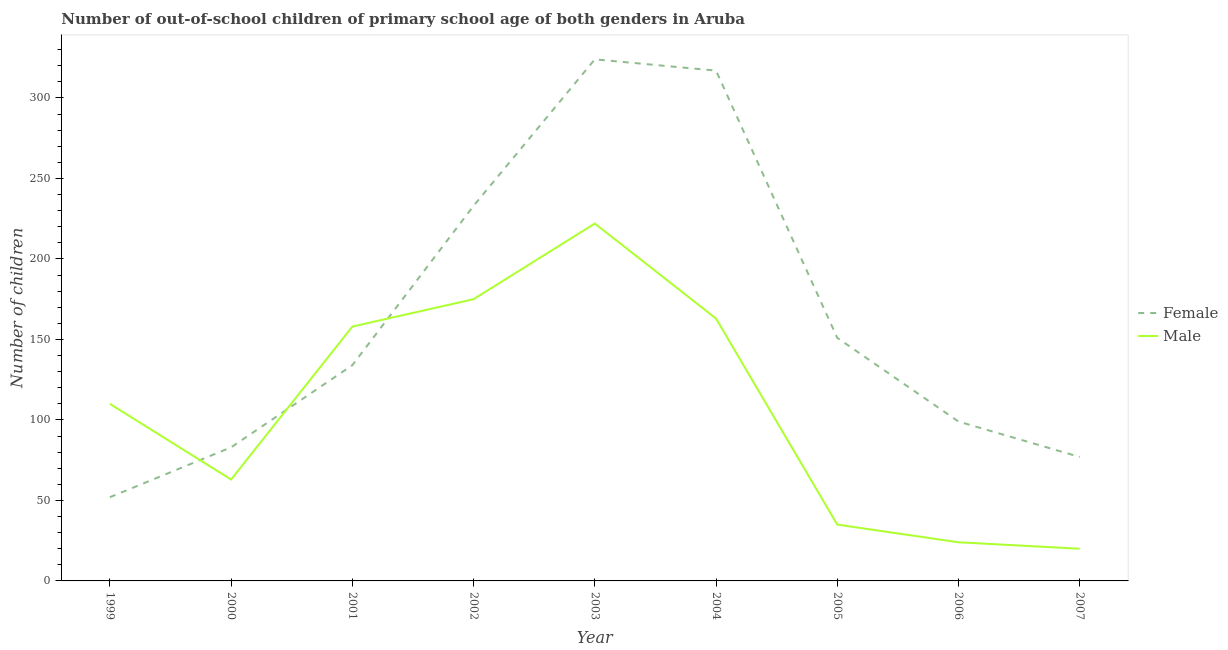Is the number of lines equal to the number of legend labels?
Your answer should be very brief. Yes. What is the number of female out-of-school students in 2006?
Make the answer very short. 99. Across all years, what is the maximum number of female out-of-school students?
Your response must be concise. 324. Across all years, what is the minimum number of male out-of-school students?
Your answer should be very brief. 20. In which year was the number of female out-of-school students maximum?
Offer a terse response. 2003. In which year was the number of male out-of-school students minimum?
Offer a very short reply. 2007. What is the total number of female out-of-school students in the graph?
Make the answer very short. 1470. What is the difference between the number of female out-of-school students in 2001 and that in 2003?
Your answer should be compact. -190. What is the difference between the number of male out-of-school students in 2006 and the number of female out-of-school students in 2002?
Make the answer very short. -209. What is the average number of female out-of-school students per year?
Provide a short and direct response. 163.33. In the year 2007, what is the difference between the number of female out-of-school students and number of male out-of-school students?
Make the answer very short. 57. What is the ratio of the number of male out-of-school students in 2002 to that in 2004?
Your response must be concise. 1.07. Is the number of female out-of-school students in 1999 less than that in 2007?
Make the answer very short. Yes. Is the difference between the number of male out-of-school students in 2000 and 2002 greater than the difference between the number of female out-of-school students in 2000 and 2002?
Your answer should be compact. Yes. What is the difference between the highest and the lowest number of female out-of-school students?
Your answer should be very brief. 272. In how many years, is the number of female out-of-school students greater than the average number of female out-of-school students taken over all years?
Your response must be concise. 3. Is the number of male out-of-school students strictly greater than the number of female out-of-school students over the years?
Offer a very short reply. No. Is the number of male out-of-school students strictly less than the number of female out-of-school students over the years?
Make the answer very short. No. How many lines are there?
Give a very brief answer. 2. Are the values on the major ticks of Y-axis written in scientific E-notation?
Your response must be concise. No. Does the graph contain grids?
Keep it short and to the point. No. Where does the legend appear in the graph?
Make the answer very short. Center right. How many legend labels are there?
Provide a short and direct response. 2. How are the legend labels stacked?
Your response must be concise. Vertical. What is the title of the graph?
Your answer should be very brief. Number of out-of-school children of primary school age of both genders in Aruba. What is the label or title of the Y-axis?
Ensure brevity in your answer.  Number of children. What is the Number of children in Male in 1999?
Provide a short and direct response. 110. What is the Number of children in Female in 2000?
Offer a terse response. 83. What is the Number of children of Female in 2001?
Your answer should be very brief. 134. What is the Number of children of Male in 2001?
Your response must be concise. 158. What is the Number of children of Female in 2002?
Provide a short and direct response. 233. What is the Number of children in Male in 2002?
Offer a terse response. 175. What is the Number of children of Female in 2003?
Keep it short and to the point. 324. What is the Number of children of Male in 2003?
Provide a succinct answer. 222. What is the Number of children in Female in 2004?
Provide a short and direct response. 317. What is the Number of children of Male in 2004?
Give a very brief answer. 163. What is the Number of children of Female in 2005?
Your response must be concise. 151. What is the Number of children in Male in 2005?
Your response must be concise. 35. What is the Number of children of Female in 2006?
Your answer should be compact. 99. Across all years, what is the maximum Number of children in Female?
Keep it short and to the point. 324. Across all years, what is the maximum Number of children of Male?
Offer a very short reply. 222. Across all years, what is the minimum Number of children of Female?
Provide a short and direct response. 52. What is the total Number of children in Female in the graph?
Ensure brevity in your answer.  1470. What is the total Number of children in Male in the graph?
Ensure brevity in your answer.  970. What is the difference between the Number of children in Female in 1999 and that in 2000?
Your answer should be compact. -31. What is the difference between the Number of children in Female in 1999 and that in 2001?
Your answer should be very brief. -82. What is the difference between the Number of children of Male in 1999 and that in 2001?
Your answer should be very brief. -48. What is the difference between the Number of children in Female in 1999 and that in 2002?
Make the answer very short. -181. What is the difference between the Number of children of Male in 1999 and that in 2002?
Ensure brevity in your answer.  -65. What is the difference between the Number of children of Female in 1999 and that in 2003?
Make the answer very short. -272. What is the difference between the Number of children in Male in 1999 and that in 2003?
Make the answer very short. -112. What is the difference between the Number of children in Female in 1999 and that in 2004?
Offer a very short reply. -265. What is the difference between the Number of children of Male in 1999 and that in 2004?
Your response must be concise. -53. What is the difference between the Number of children in Female in 1999 and that in 2005?
Your answer should be compact. -99. What is the difference between the Number of children in Male in 1999 and that in 2005?
Provide a short and direct response. 75. What is the difference between the Number of children in Female in 1999 and that in 2006?
Offer a very short reply. -47. What is the difference between the Number of children of Male in 1999 and that in 2007?
Give a very brief answer. 90. What is the difference between the Number of children in Female in 2000 and that in 2001?
Give a very brief answer. -51. What is the difference between the Number of children in Male in 2000 and that in 2001?
Provide a succinct answer. -95. What is the difference between the Number of children in Female in 2000 and that in 2002?
Your answer should be very brief. -150. What is the difference between the Number of children in Male in 2000 and that in 2002?
Offer a very short reply. -112. What is the difference between the Number of children of Female in 2000 and that in 2003?
Your answer should be very brief. -241. What is the difference between the Number of children in Male in 2000 and that in 2003?
Provide a short and direct response. -159. What is the difference between the Number of children in Female in 2000 and that in 2004?
Your response must be concise. -234. What is the difference between the Number of children in Male in 2000 and that in 2004?
Offer a very short reply. -100. What is the difference between the Number of children of Female in 2000 and that in 2005?
Provide a short and direct response. -68. What is the difference between the Number of children of Male in 2000 and that in 2005?
Ensure brevity in your answer.  28. What is the difference between the Number of children in Male in 2000 and that in 2006?
Provide a succinct answer. 39. What is the difference between the Number of children in Male in 2000 and that in 2007?
Offer a terse response. 43. What is the difference between the Number of children of Female in 2001 and that in 2002?
Your answer should be compact. -99. What is the difference between the Number of children of Male in 2001 and that in 2002?
Give a very brief answer. -17. What is the difference between the Number of children in Female in 2001 and that in 2003?
Offer a terse response. -190. What is the difference between the Number of children of Male in 2001 and that in 2003?
Make the answer very short. -64. What is the difference between the Number of children of Female in 2001 and that in 2004?
Your answer should be very brief. -183. What is the difference between the Number of children of Male in 2001 and that in 2004?
Give a very brief answer. -5. What is the difference between the Number of children of Female in 2001 and that in 2005?
Your response must be concise. -17. What is the difference between the Number of children of Male in 2001 and that in 2005?
Provide a short and direct response. 123. What is the difference between the Number of children of Female in 2001 and that in 2006?
Make the answer very short. 35. What is the difference between the Number of children in Male in 2001 and that in 2006?
Your answer should be compact. 134. What is the difference between the Number of children of Female in 2001 and that in 2007?
Your response must be concise. 57. What is the difference between the Number of children of Male in 2001 and that in 2007?
Make the answer very short. 138. What is the difference between the Number of children of Female in 2002 and that in 2003?
Your answer should be very brief. -91. What is the difference between the Number of children in Male in 2002 and that in 2003?
Offer a very short reply. -47. What is the difference between the Number of children of Female in 2002 and that in 2004?
Your answer should be very brief. -84. What is the difference between the Number of children of Male in 2002 and that in 2004?
Ensure brevity in your answer.  12. What is the difference between the Number of children of Male in 2002 and that in 2005?
Keep it short and to the point. 140. What is the difference between the Number of children in Female in 2002 and that in 2006?
Offer a very short reply. 134. What is the difference between the Number of children of Male in 2002 and that in 2006?
Offer a terse response. 151. What is the difference between the Number of children in Female in 2002 and that in 2007?
Your response must be concise. 156. What is the difference between the Number of children of Male in 2002 and that in 2007?
Keep it short and to the point. 155. What is the difference between the Number of children of Female in 2003 and that in 2004?
Make the answer very short. 7. What is the difference between the Number of children of Male in 2003 and that in 2004?
Make the answer very short. 59. What is the difference between the Number of children of Female in 2003 and that in 2005?
Your response must be concise. 173. What is the difference between the Number of children of Male in 2003 and that in 2005?
Your response must be concise. 187. What is the difference between the Number of children in Female in 2003 and that in 2006?
Offer a very short reply. 225. What is the difference between the Number of children in Male in 2003 and that in 2006?
Your answer should be very brief. 198. What is the difference between the Number of children of Female in 2003 and that in 2007?
Offer a terse response. 247. What is the difference between the Number of children in Male in 2003 and that in 2007?
Make the answer very short. 202. What is the difference between the Number of children of Female in 2004 and that in 2005?
Keep it short and to the point. 166. What is the difference between the Number of children in Male in 2004 and that in 2005?
Make the answer very short. 128. What is the difference between the Number of children of Female in 2004 and that in 2006?
Make the answer very short. 218. What is the difference between the Number of children in Male in 2004 and that in 2006?
Provide a succinct answer. 139. What is the difference between the Number of children of Female in 2004 and that in 2007?
Keep it short and to the point. 240. What is the difference between the Number of children of Male in 2004 and that in 2007?
Provide a succinct answer. 143. What is the difference between the Number of children of Male in 2005 and that in 2006?
Provide a short and direct response. 11. What is the difference between the Number of children of Female in 2006 and that in 2007?
Your answer should be very brief. 22. What is the difference between the Number of children in Male in 2006 and that in 2007?
Offer a very short reply. 4. What is the difference between the Number of children in Female in 1999 and the Number of children in Male in 2001?
Make the answer very short. -106. What is the difference between the Number of children in Female in 1999 and the Number of children in Male in 2002?
Keep it short and to the point. -123. What is the difference between the Number of children of Female in 1999 and the Number of children of Male in 2003?
Offer a very short reply. -170. What is the difference between the Number of children in Female in 1999 and the Number of children in Male in 2004?
Ensure brevity in your answer.  -111. What is the difference between the Number of children of Female in 1999 and the Number of children of Male in 2007?
Provide a short and direct response. 32. What is the difference between the Number of children in Female in 2000 and the Number of children in Male in 2001?
Offer a terse response. -75. What is the difference between the Number of children of Female in 2000 and the Number of children of Male in 2002?
Your response must be concise. -92. What is the difference between the Number of children of Female in 2000 and the Number of children of Male in 2003?
Give a very brief answer. -139. What is the difference between the Number of children of Female in 2000 and the Number of children of Male in 2004?
Give a very brief answer. -80. What is the difference between the Number of children in Female in 2000 and the Number of children in Male in 2005?
Your answer should be compact. 48. What is the difference between the Number of children in Female in 2001 and the Number of children in Male in 2002?
Give a very brief answer. -41. What is the difference between the Number of children in Female in 2001 and the Number of children in Male in 2003?
Keep it short and to the point. -88. What is the difference between the Number of children in Female in 2001 and the Number of children in Male in 2004?
Offer a very short reply. -29. What is the difference between the Number of children in Female in 2001 and the Number of children in Male in 2005?
Offer a terse response. 99. What is the difference between the Number of children of Female in 2001 and the Number of children of Male in 2006?
Provide a succinct answer. 110. What is the difference between the Number of children in Female in 2001 and the Number of children in Male in 2007?
Provide a succinct answer. 114. What is the difference between the Number of children of Female in 2002 and the Number of children of Male in 2004?
Provide a succinct answer. 70. What is the difference between the Number of children of Female in 2002 and the Number of children of Male in 2005?
Provide a succinct answer. 198. What is the difference between the Number of children of Female in 2002 and the Number of children of Male in 2006?
Make the answer very short. 209. What is the difference between the Number of children in Female in 2002 and the Number of children in Male in 2007?
Provide a short and direct response. 213. What is the difference between the Number of children in Female in 2003 and the Number of children in Male in 2004?
Give a very brief answer. 161. What is the difference between the Number of children of Female in 2003 and the Number of children of Male in 2005?
Your answer should be compact. 289. What is the difference between the Number of children in Female in 2003 and the Number of children in Male in 2006?
Ensure brevity in your answer.  300. What is the difference between the Number of children in Female in 2003 and the Number of children in Male in 2007?
Your response must be concise. 304. What is the difference between the Number of children of Female in 2004 and the Number of children of Male in 2005?
Provide a short and direct response. 282. What is the difference between the Number of children in Female in 2004 and the Number of children in Male in 2006?
Ensure brevity in your answer.  293. What is the difference between the Number of children of Female in 2004 and the Number of children of Male in 2007?
Offer a terse response. 297. What is the difference between the Number of children of Female in 2005 and the Number of children of Male in 2006?
Offer a very short reply. 127. What is the difference between the Number of children of Female in 2005 and the Number of children of Male in 2007?
Offer a very short reply. 131. What is the difference between the Number of children of Female in 2006 and the Number of children of Male in 2007?
Keep it short and to the point. 79. What is the average Number of children in Female per year?
Ensure brevity in your answer.  163.33. What is the average Number of children in Male per year?
Give a very brief answer. 107.78. In the year 1999, what is the difference between the Number of children of Female and Number of children of Male?
Give a very brief answer. -58. In the year 2000, what is the difference between the Number of children in Female and Number of children in Male?
Your answer should be very brief. 20. In the year 2001, what is the difference between the Number of children of Female and Number of children of Male?
Give a very brief answer. -24. In the year 2003, what is the difference between the Number of children of Female and Number of children of Male?
Your answer should be compact. 102. In the year 2004, what is the difference between the Number of children in Female and Number of children in Male?
Ensure brevity in your answer.  154. In the year 2005, what is the difference between the Number of children in Female and Number of children in Male?
Your response must be concise. 116. What is the ratio of the Number of children in Female in 1999 to that in 2000?
Offer a terse response. 0.63. What is the ratio of the Number of children in Male in 1999 to that in 2000?
Ensure brevity in your answer.  1.75. What is the ratio of the Number of children of Female in 1999 to that in 2001?
Keep it short and to the point. 0.39. What is the ratio of the Number of children in Male in 1999 to that in 2001?
Ensure brevity in your answer.  0.7. What is the ratio of the Number of children in Female in 1999 to that in 2002?
Keep it short and to the point. 0.22. What is the ratio of the Number of children in Male in 1999 to that in 2002?
Keep it short and to the point. 0.63. What is the ratio of the Number of children of Female in 1999 to that in 2003?
Offer a terse response. 0.16. What is the ratio of the Number of children of Male in 1999 to that in 2003?
Your answer should be very brief. 0.5. What is the ratio of the Number of children in Female in 1999 to that in 2004?
Provide a succinct answer. 0.16. What is the ratio of the Number of children of Male in 1999 to that in 2004?
Your answer should be very brief. 0.67. What is the ratio of the Number of children of Female in 1999 to that in 2005?
Give a very brief answer. 0.34. What is the ratio of the Number of children of Male in 1999 to that in 2005?
Offer a very short reply. 3.14. What is the ratio of the Number of children in Female in 1999 to that in 2006?
Provide a short and direct response. 0.53. What is the ratio of the Number of children in Male in 1999 to that in 2006?
Give a very brief answer. 4.58. What is the ratio of the Number of children in Female in 1999 to that in 2007?
Ensure brevity in your answer.  0.68. What is the ratio of the Number of children of Female in 2000 to that in 2001?
Ensure brevity in your answer.  0.62. What is the ratio of the Number of children of Male in 2000 to that in 2001?
Your answer should be compact. 0.4. What is the ratio of the Number of children in Female in 2000 to that in 2002?
Offer a terse response. 0.36. What is the ratio of the Number of children in Male in 2000 to that in 2002?
Provide a succinct answer. 0.36. What is the ratio of the Number of children in Female in 2000 to that in 2003?
Provide a short and direct response. 0.26. What is the ratio of the Number of children of Male in 2000 to that in 2003?
Make the answer very short. 0.28. What is the ratio of the Number of children of Female in 2000 to that in 2004?
Ensure brevity in your answer.  0.26. What is the ratio of the Number of children of Male in 2000 to that in 2004?
Give a very brief answer. 0.39. What is the ratio of the Number of children of Female in 2000 to that in 2005?
Make the answer very short. 0.55. What is the ratio of the Number of children in Female in 2000 to that in 2006?
Your answer should be compact. 0.84. What is the ratio of the Number of children of Male in 2000 to that in 2006?
Your answer should be compact. 2.62. What is the ratio of the Number of children of Female in 2000 to that in 2007?
Offer a terse response. 1.08. What is the ratio of the Number of children of Male in 2000 to that in 2007?
Offer a very short reply. 3.15. What is the ratio of the Number of children of Female in 2001 to that in 2002?
Your answer should be very brief. 0.58. What is the ratio of the Number of children of Male in 2001 to that in 2002?
Make the answer very short. 0.9. What is the ratio of the Number of children in Female in 2001 to that in 2003?
Provide a succinct answer. 0.41. What is the ratio of the Number of children of Male in 2001 to that in 2003?
Make the answer very short. 0.71. What is the ratio of the Number of children in Female in 2001 to that in 2004?
Offer a very short reply. 0.42. What is the ratio of the Number of children of Male in 2001 to that in 2004?
Keep it short and to the point. 0.97. What is the ratio of the Number of children of Female in 2001 to that in 2005?
Offer a terse response. 0.89. What is the ratio of the Number of children of Male in 2001 to that in 2005?
Your answer should be very brief. 4.51. What is the ratio of the Number of children in Female in 2001 to that in 2006?
Your answer should be compact. 1.35. What is the ratio of the Number of children of Male in 2001 to that in 2006?
Offer a terse response. 6.58. What is the ratio of the Number of children in Female in 2001 to that in 2007?
Your answer should be very brief. 1.74. What is the ratio of the Number of children of Female in 2002 to that in 2003?
Give a very brief answer. 0.72. What is the ratio of the Number of children of Male in 2002 to that in 2003?
Offer a very short reply. 0.79. What is the ratio of the Number of children of Female in 2002 to that in 2004?
Ensure brevity in your answer.  0.73. What is the ratio of the Number of children of Male in 2002 to that in 2004?
Offer a terse response. 1.07. What is the ratio of the Number of children in Female in 2002 to that in 2005?
Make the answer very short. 1.54. What is the ratio of the Number of children in Male in 2002 to that in 2005?
Offer a very short reply. 5. What is the ratio of the Number of children in Female in 2002 to that in 2006?
Ensure brevity in your answer.  2.35. What is the ratio of the Number of children of Male in 2002 to that in 2006?
Offer a very short reply. 7.29. What is the ratio of the Number of children in Female in 2002 to that in 2007?
Provide a short and direct response. 3.03. What is the ratio of the Number of children in Male in 2002 to that in 2007?
Offer a very short reply. 8.75. What is the ratio of the Number of children of Female in 2003 to that in 2004?
Ensure brevity in your answer.  1.02. What is the ratio of the Number of children of Male in 2003 to that in 2004?
Provide a short and direct response. 1.36. What is the ratio of the Number of children of Female in 2003 to that in 2005?
Provide a succinct answer. 2.15. What is the ratio of the Number of children in Male in 2003 to that in 2005?
Your response must be concise. 6.34. What is the ratio of the Number of children of Female in 2003 to that in 2006?
Provide a short and direct response. 3.27. What is the ratio of the Number of children of Male in 2003 to that in 2006?
Provide a succinct answer. 9.25. What is the ratio of the Number of children of Female in 2003 to that in 2007?
Provide a succinct answer. 4.21. What is the ratio of the Number of children of Female in 2004 to that in 2005?
Offer a very short reply. 2.1. What is the ratio of the Number of children in Male in 2004 to that in 2005?
Your response must be concise. 4.66. What is the ratio of the Number of children of Female in 2004 to that in 2006?
Offer a terse response. 3.2. What is the ratio of the Number of children of Male in 2004 to that in 2006?
Offer a terse response. 6.79. What is the ratio of the Number of children of Female in 2004 to that in 2007?
Offer a terse response. 4.12. What is the ratio of the Number of children in Male in 2004 to that in 2007?
Keep it short and to the point. 8.15. What is the ratio of the Number of children in Female in 2005 to that in 2006?
Give a very brief answer. 1.53. What is the ratio of the Number of children of Male in 2005 to that in 2006?
Provide a short and direct response. 1.46. What is the ratio of the Number of children in Female in 2005 to that in 2007?
Offer a terse response. 1.96. What is the ratio of the Number of children in Female in 2006 to that in 2007?
Keep it short and to the point. 1.29. What is the difference between the highest and the second highest Number of children in Female?
Give a very brief answer. 7. What is the difference between the highest and the lowest Number of children of Female?
Provide a short and direct response. 272. What is the difference between the highest and the lowest Number of children in Male?
Your answer should be compact. 202. 